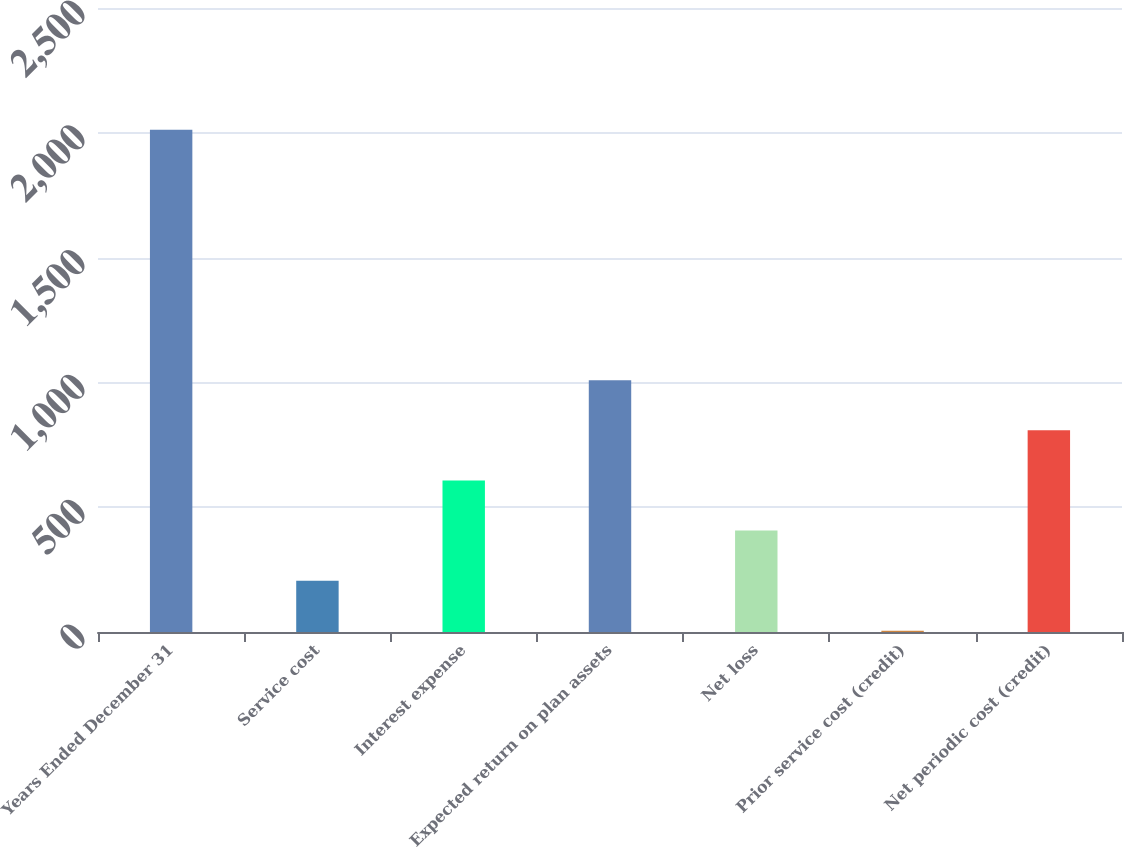Convert chart to OTSL. <chart><loc_0><loc_0><loc_500><loc_500><bar_chart><fcel>Years Ended December 31<fcel>Service cost<fcel>Interest expense<fcel>Expected return on plan assets<fcel>Net loss<fcel>Prior service cost (credit)<fcel>Net periodic cost (credit)<nl><fcel>2012<fcel>205.7<fcel>607.1<fcel>1008.5<fcel>406.4<fcel>5<fcel>807.8<nl></chart> 